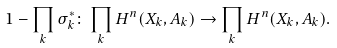Convert formula to latex. <formula><loc_0><loc_0><loc_500><loc_500>1 - \prod _ { k } \sigma _ { k } ^ { * } \colon \prod _ { k } H ^ { n } ( X _ { k } , A _ { k } ) \rightarrow \prod _ { k } H ^ { n } ( X _ { k } , A _ { k } ) .</formula> 